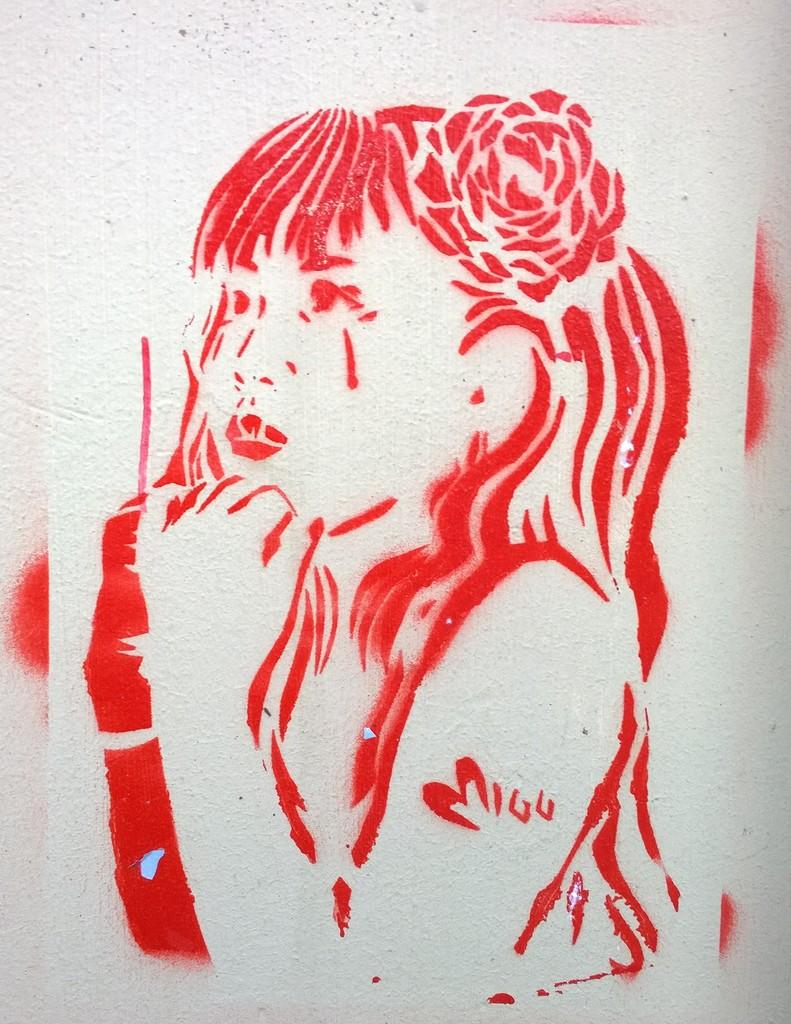What is the main subject of the image? There is a painting in the image. What does the painting depict? The painting depicts a woman. Where is the painting located? The painting is on a wall. What type of note is the woman holding in the painting? The image does not show the woman holding any note, as it is a painting of a woman on a wall. 